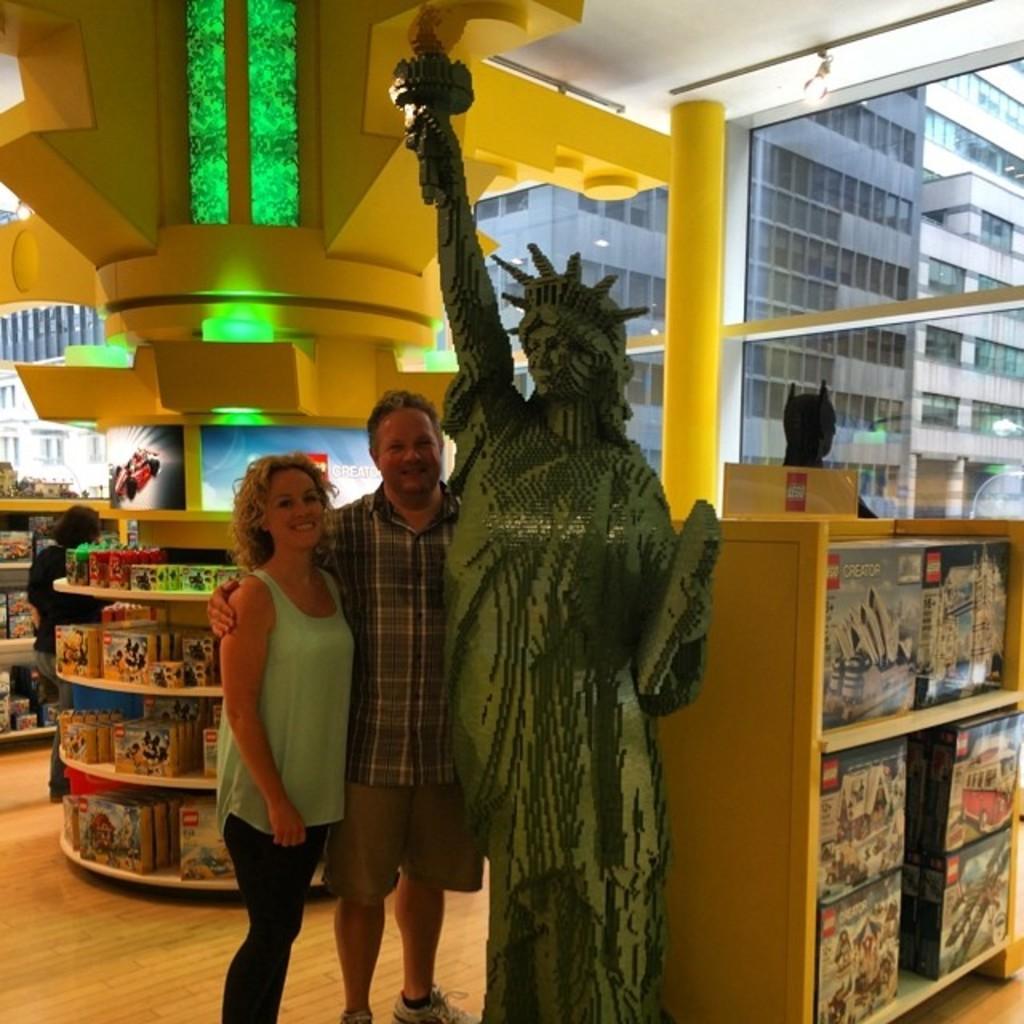Can you describe this image briefly? In this image I can see the statue and I can also see two persons standing. The person at left is wearing green and black color dress and the person at right is wearing white, gray and cream color dress. Background I can see few cardboard boxes on the racks and I can see few lights, background I can see few buildings in brown and gray color. 